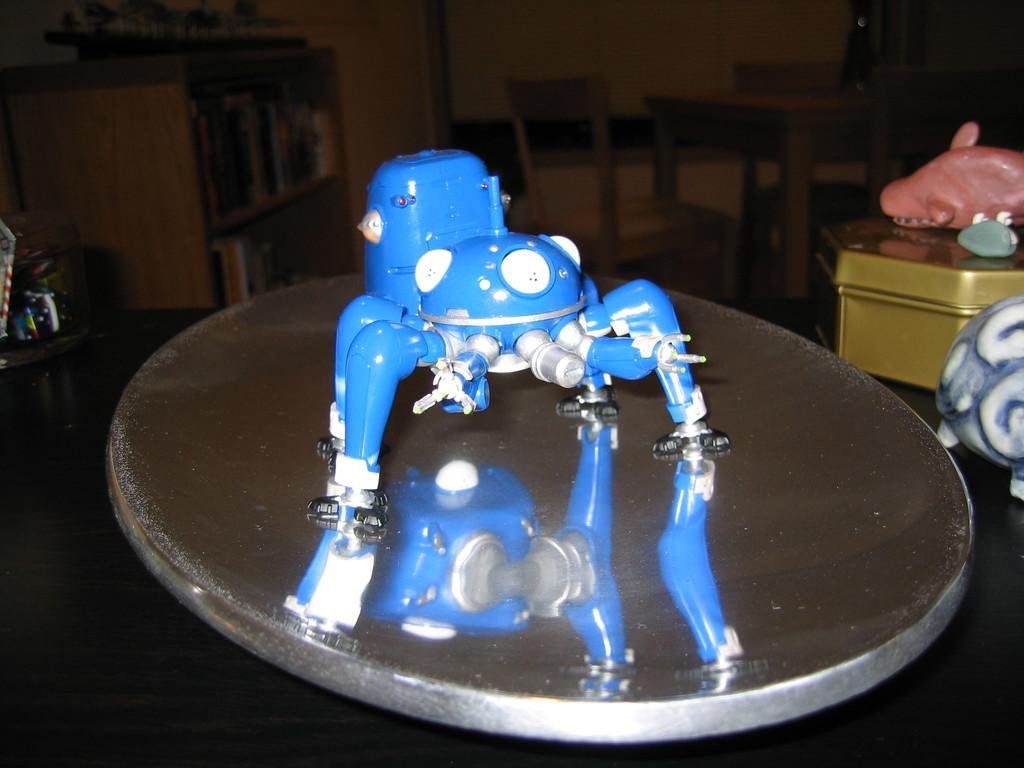What is placed on a steel object in the image? There is a machine placed on a steel object in the image. What other objects can be seen near the machine? There are additional objects near the machine. What can be seen in the background of the image? There is a table, chairs, cupboards, and a wall in the background of the image. Is there a volcano visible in the image? No, there is no volcano present in the image. What type of oven is used in the image? There is no oven present in the image. 